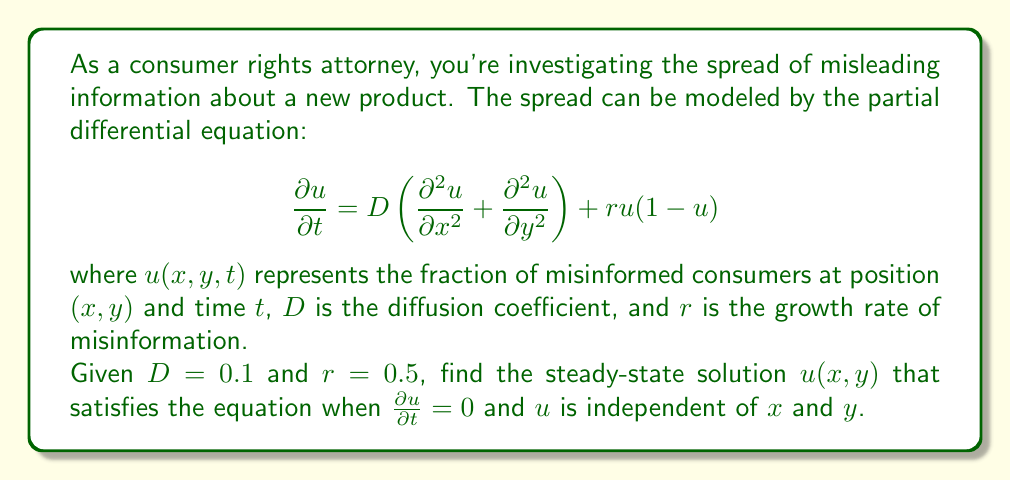Show me your answer to this math problem. To solve this problem, we'll follow these steps:

1) First, we note that for a steady-state solution, $\frac{\partial u}{\partial t} = 0$. 

2) We're also told that $u$ is independent of $x$ and $y$, which means $\frac{\partial^2 u}{\partial x^2} = \frac{\partial^2 u}{\partial y^2} = 0$.

3) Substituting these into our original equation:

   $$0 = D(0 + 0) + ru(1-u)$$

4) Simplifying:

   $$0 = ru(1-u)$$

5) We can factor this:

   $$0 = ru(1-u) = r(u-0)(1-u)$$

6) For this equation to be true, either $u = 0$ or $u = 1$ (since $r \neq 0$).

7) Both of these solutions satisfy our equation. However, $u = 0$ represents no misinformation at all, which is not typically the case in real-world scenarios. Therefore, the more relevant steady-state solution is $u = 1$.

This solution indicates that, in the long run and without intervention, misinformation spreads to the entire population.
Answer: The steady-state solution is $u(x,y) = 1$. 